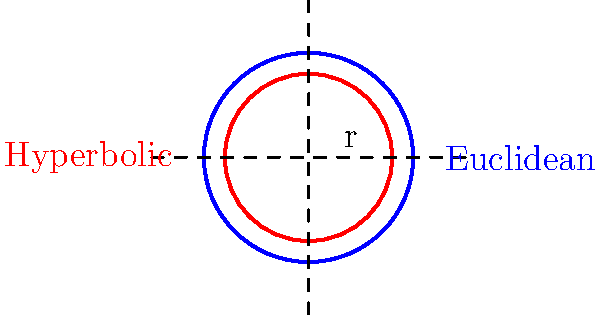In a fundraising event, you're tasked with comparing circular event spaces in different geometries. Given a circle with radius $r$ in both Euclidean and hyperbolic geometries, how does the ratio of their areas (Hyperbolic:Euclidean) change as $r$ approaches infinity? Assume the hyperbolic plane has a constant curvature of $-1$. To solve this problem, let's follow these steps:

1) First, recall the area formulas for circles in both geometries:

   Euclidean: $A_E = \pi r^2$
   Hyperbolic: $A_H = 4\pi \sinh^2(\frac{r}{2})$

2) The ratio of areas (Hyperbolic:Euclidean) is:

   $\frac{A_H}{A_E} = \frac{4\pi \sinh^2(\frac{r}{2})}{\pi r^2} = \frac{4 \sinh^2(\frac{r}{2})}{r^2}$

3) As $r$ approaches infinity, we need to evaluate the limit:

   $\lim_{r \to \infty} \frac{4 \sinh^2(\frac{r}{2})}{r^2}$

4) Recall that for large $x$, $\sinh(x) \approx \frac{e^x}{2}$. Applying this:

   $\lim_{r \to \infty} \frac{4 (\frac{e^{r/2}}{2})^2}{r^2} = \lim_{r \to \infty} \frac{e^r}{r^2}$

5) This limit can be evaluated using L'Hôpital's rule twice:

   $\lim_{r \to \infty} \frac{e^r}{r^2} = \lim_{r \to \infty} \frac{e^r}{2r} = \lim_{r \to \infty} \frac{e^r}{2} = \infty$

6) Therefore, as $r$ approaches infinity, the ratio of the hyperbolic area to the Euclidean area approaches infinity.

This result shows that in hyperbolic geometry, the area of a circle grows much faster than in Euclidean geometry as the radius increases.
Answer: The ratio approaches infinity. 